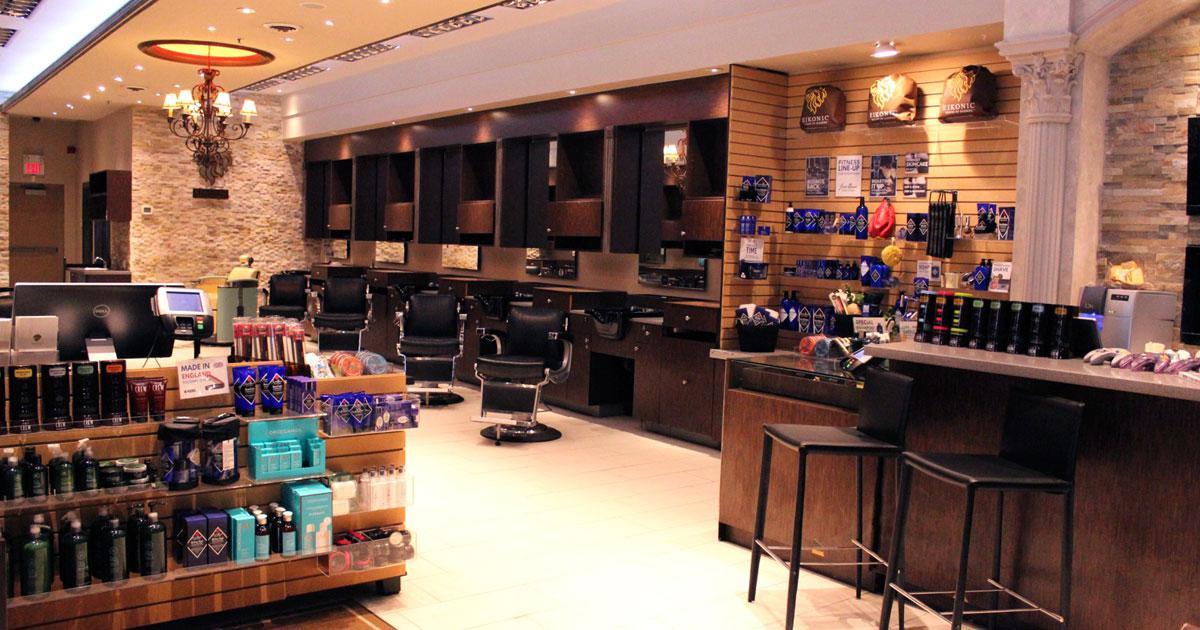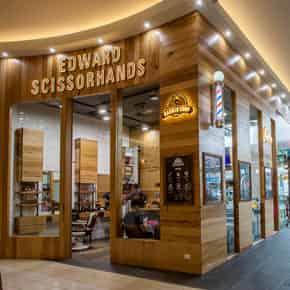The first image is the image on the left, the second image is the image on the right. Evaluate the accuracy of this statement regarding the images: "There is a barber pole in the image on the right.". Is it true? Answer yes or no. Yes. 